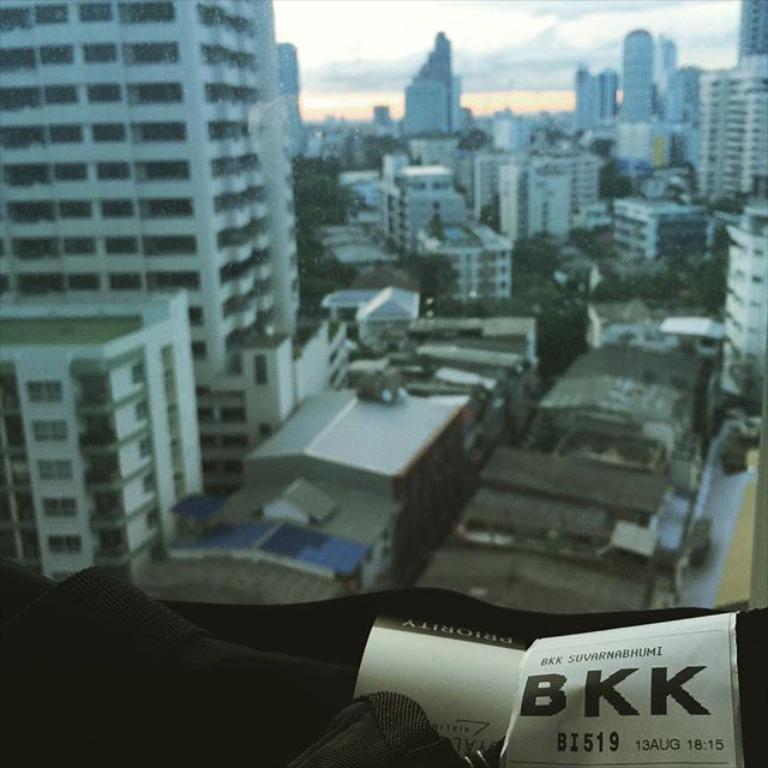Please provide a concise description of this image. In this image we can see buildings, trees and there is a sky at the top of this image. We can see a black color object at the bottom of this image. 